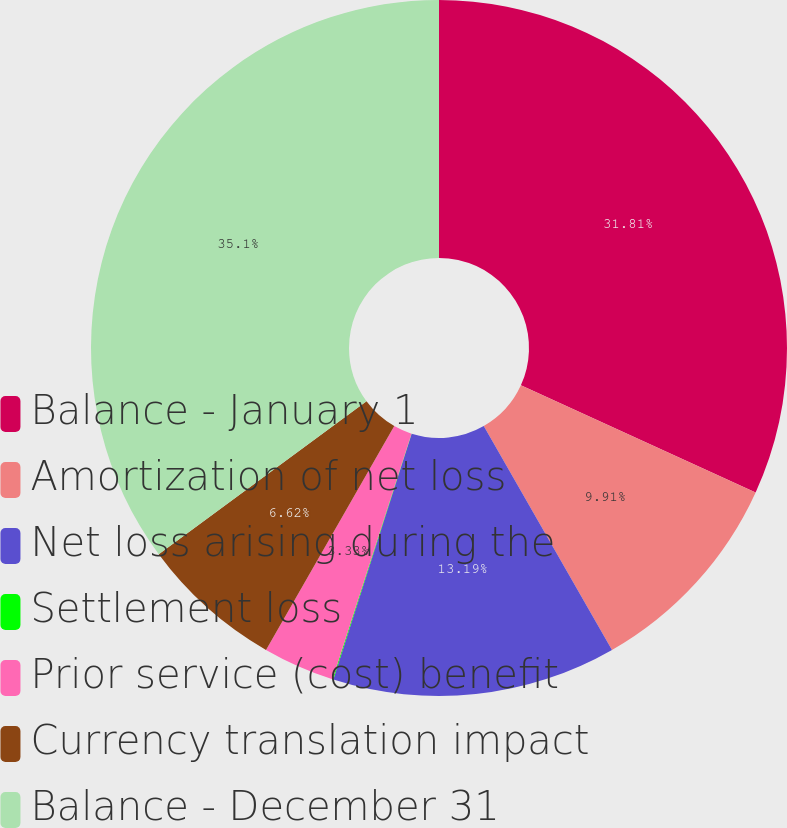Convert chart. <chart><loc_0><loc_0><loc_500><loc_500><pie_chart><fcel>Balance - January 1<fcel>Amortization of net loss<fcel>Net loss arising during the<fcel>Settlement loss<fcel>Prior service (cost) benefit<fcel>Currency translation impact<fcel>Balance - December 31<nl><fcel>31.81%<fcel>9.91%<fcel>13.19%<fcel>0.04%<fcel>3.33%<fcel>6.62%<fcel>35.1%<nl></chart> 